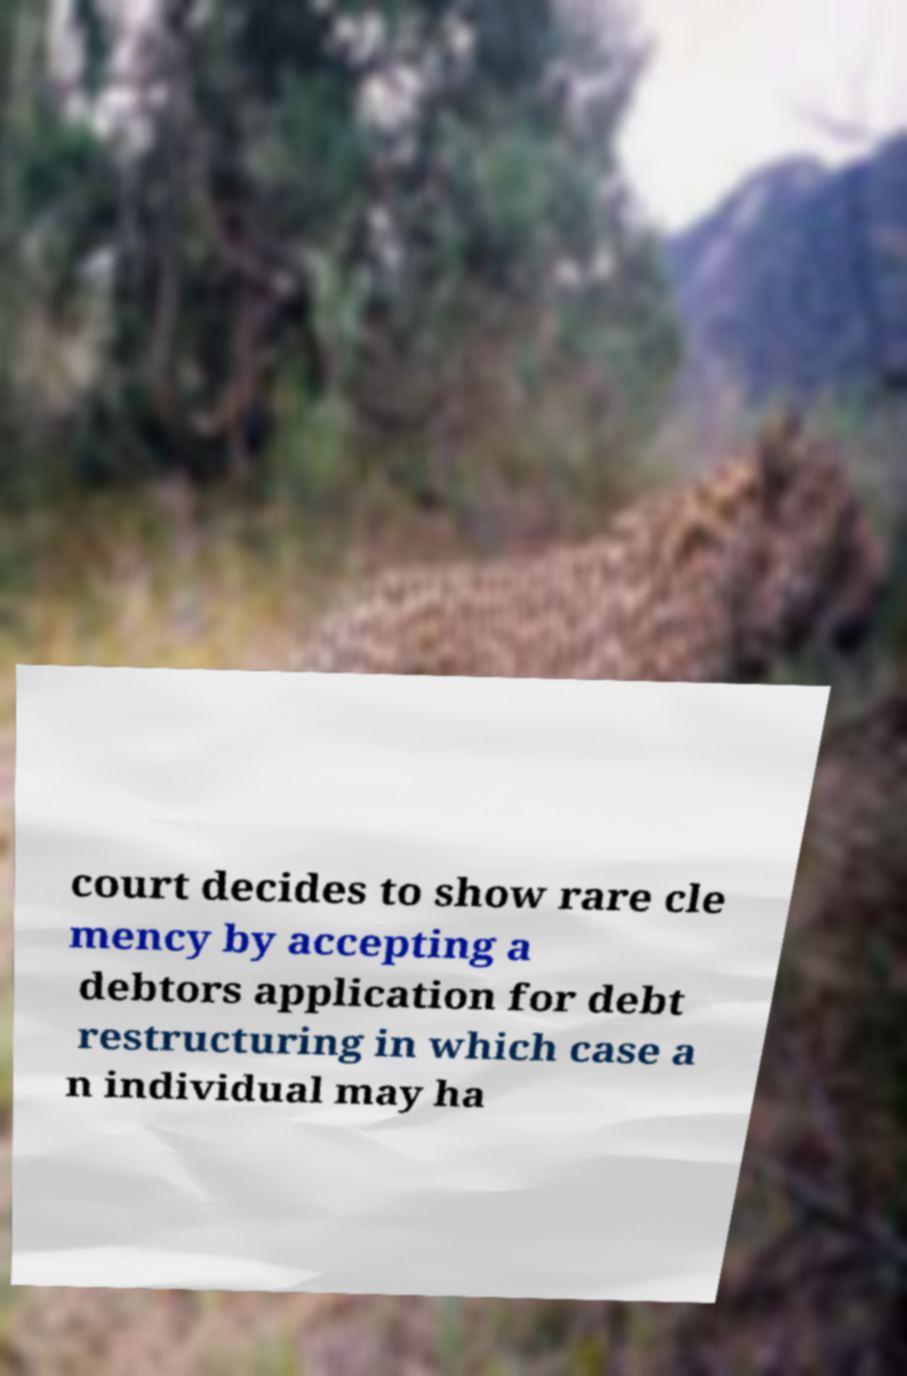Please read and relay the text visible in this image. What does it say? court decides to show rare cle mency by accepting a debtors application for debt restructuring in which case a n individual may ha 